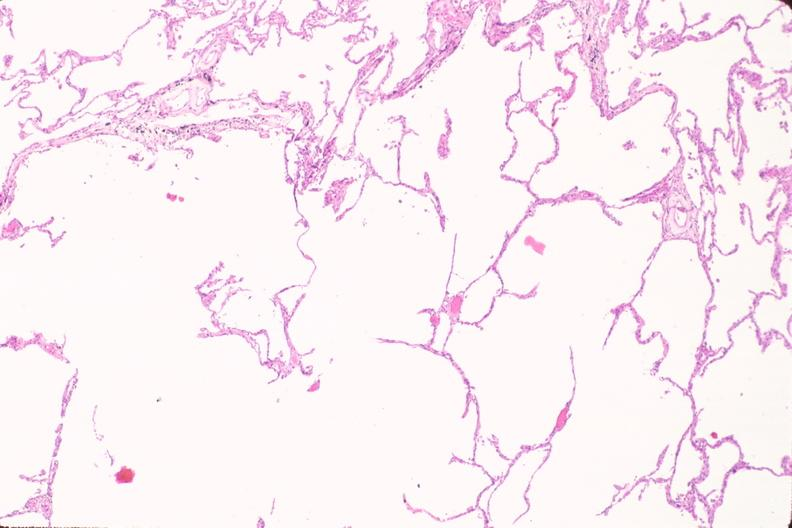where is this?
Answer the question using a single word or phrase. Lung 